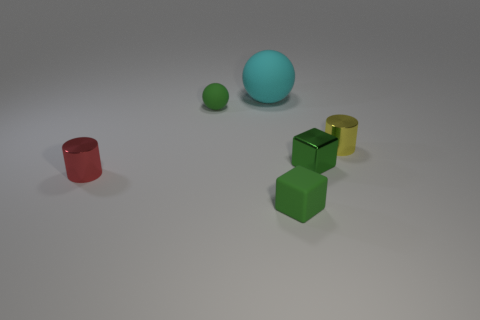Add 1 large gray things. How many objects exist? 7 Subtract all green balls. How many balls are left? 1 Subtract all cylinders. How many objects are left? 4 Subtract 1 cylinders. How many cylinders are left? 1 Subtract all large matte things. Subtract all yellow shiny cylinders. How many objects are left? 4 Add 5 yellow cylinders. How many yellow cylinders are left? 6 Add 5 large rubber balls. How many large rubber balls exist? 6 Subtract 0 gray cubes. How many objects are left? 6 Subtract all red spheres. Subtract all blue blocks. How many spheres are left? 2 Subtract all purple blocks. How many red balls are left? 0 